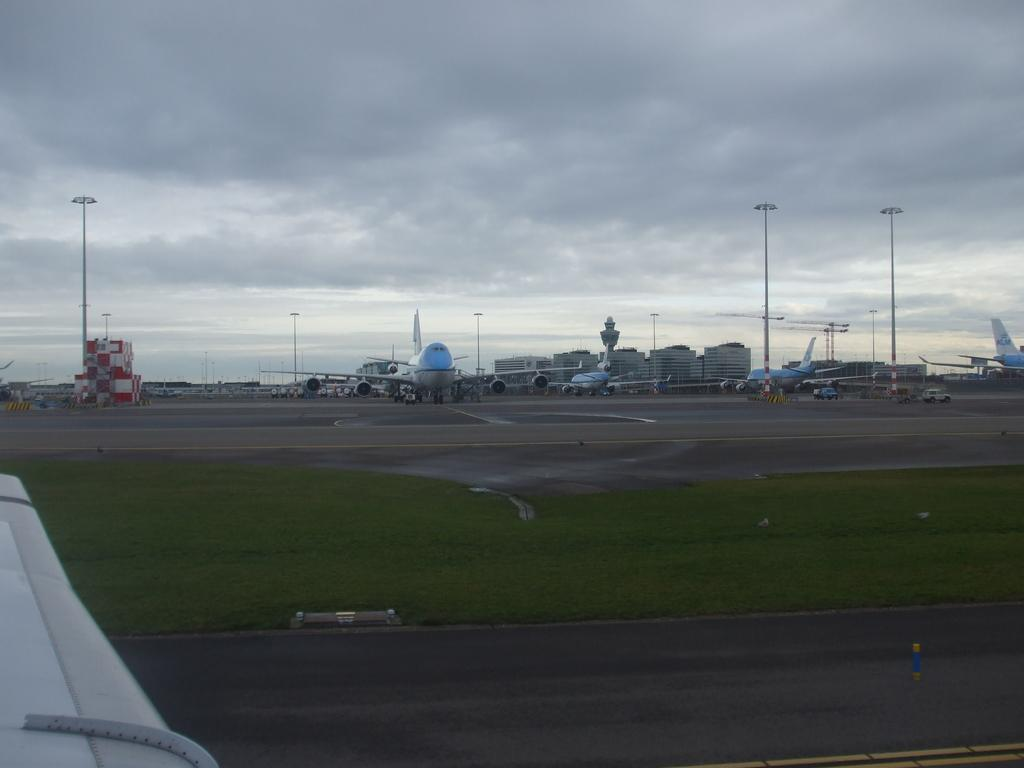What can be seen on the runway in the image? There are planes on the runway in the image. What can be seen in the distance behind the runway? There are buildings visible in the background of the image. What type of infrastructure is present in the image? Electric poles are present in the image. Can you see any flowers growing near the electric poles in the image? There are no flowers visible in the image; it primarily features planes, buildings, and electric poles. 